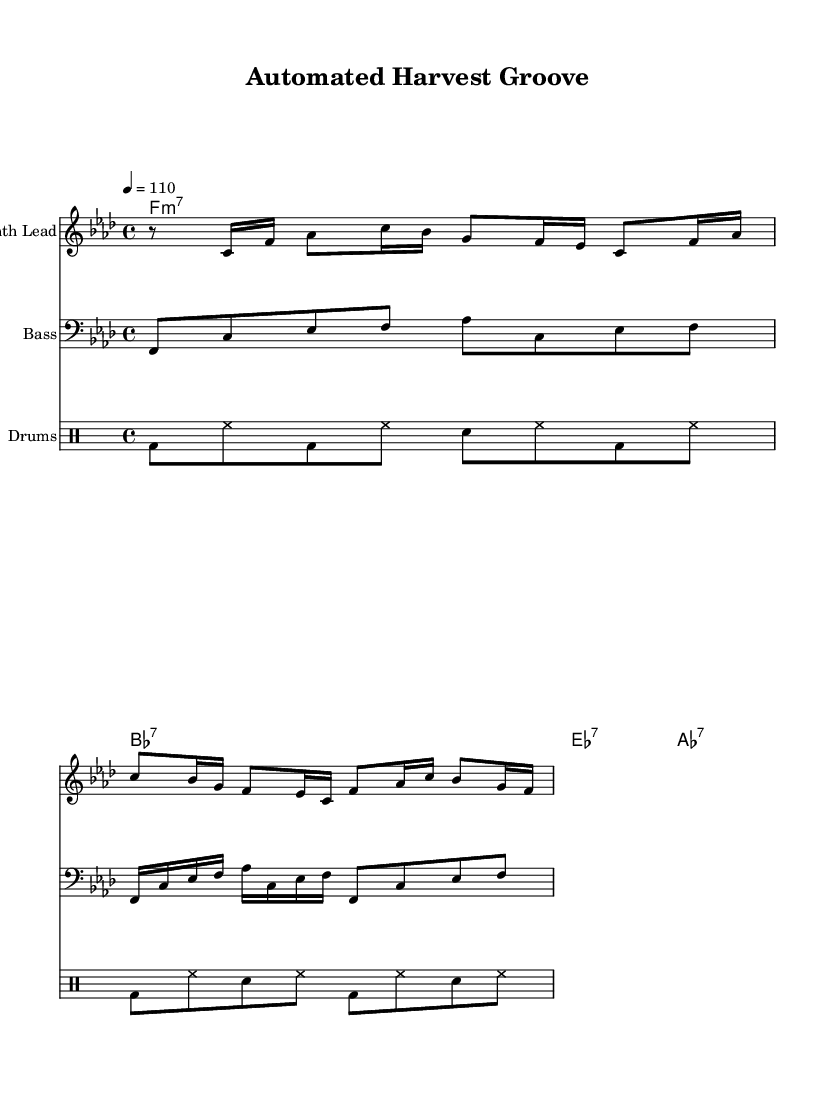What is the key signature of this music? The key signature is indicated at the beginning of the score. It shows four flats, which corresponds to F minor.
Answer: F minor What is the time signature of the piece? The time signature is located right after the key signature in the score. Here, it is written as 4/4, meaning there are four beats in each measure and the quarter note gets one beat.
Answer: 4/4 What is the tempo marking for this composition? The tempo marking is shown in the score with a number followed by an equal sign. In this case, it says 4 = 110, which indicates the tempo in beats per minute.
Answer: 110 How many measures does the bass line have? The bass line staff shows the notes grouped within bar lines. Counting the bar lines in the provided bass line indicates there are four measures.
Answer: 4 Which instrument has the highest pitch range? By analyzing the score, we review the different staves. The synth lead has notes that reach higher pitches compared to both bass and drums, indicating it has the highest pitch range.
Answer: Synth Lead What type of chords is used in the progression? The chords shown in the chord names staff provide the harmonic structure. Each chord is marked with a type, such as m7 (minor seventh) or 7 (dominant seventh). In this case, they have a mix of seventh chords.
Answer: Seventh chords What rhythmic pattern is emphasized in the drum section? Looking closely at the drum staff, the pattern primarily uses bass drum and hi-hat (bd and hh), and their consistent repetition in the measures emphasizes the groove characteristic of Funk music.
Answer: Bass and hi-hat 